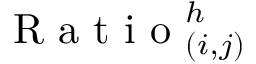Convert formula to latex. <formula><loc_0><loc_0><loc_500><loc_500>R a t i o _ { ( i , j ) } ^ { h }</formula> 